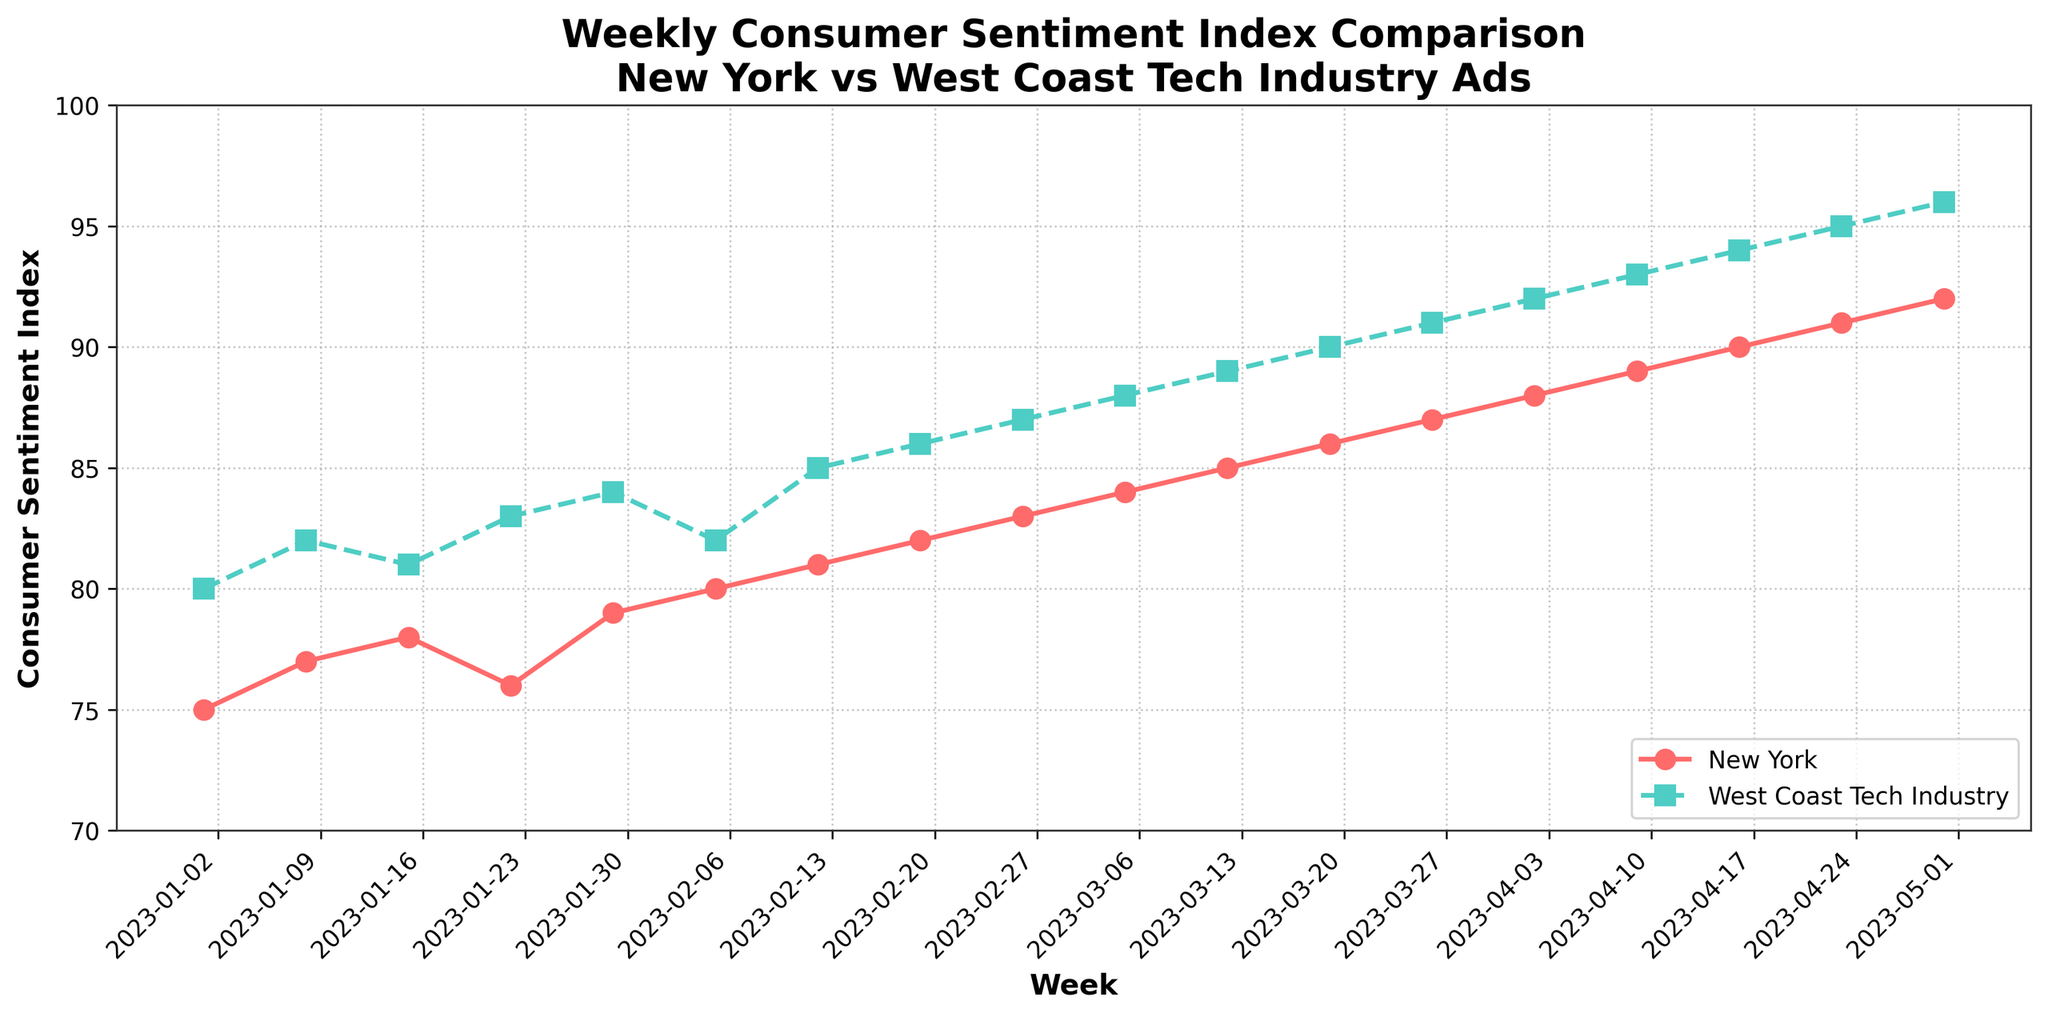How many weeks are displayed in the figure? The x-axis displays the range of dates from the first week of January 2023 to the last week of April 2023. Counting the data points from January 1, 2023, to April 30, 2023, results in 18 weeks.
Answer: 18 What is the title of the figure? The title is directly mentioned at the top of the plot.
Answer: Weekly Consumer Sentiment Index Comparison Between New York and West Coast Tech Industry Ads Which region has a higher consumer sentiment index on 2023-02-26? By inspecting the plot on the week of February 26, the West Coast line is above the New York line.
Answer: West Coast How much did the consumer sentiment index for New York increase from January 1, 2023, to April 30, 2023? Identify the consumer sentiment index for New York on January 1 (75) and April 30 (92) and calculate the difference (92 - 75).
Answer: 17 On which week did both regions have the same consumer sentiment index? By inspecting the plot, the lines for New York and West Coast are equal at the week of February 5 where both show an index of 80.
Answer: 2023-02-05 What is the overall trend of the consumer sentiment index for both regions? The plot shows an upward trend for both New York and the West Coast tech industry ads, as indicated by the increasing values over time.
Answer: Upward Which region had the steepest increase in consumer sentiment index in a single week, and when did it occur? By comparing the week-to-week changes, the West Coast had an increase from 91 to 92 between April 2, 2023, and April 9, 2023, which is a 1-point increase, while New York had several weeks with 1-point increases but none larger.
Answer: April 9, West Coast Is there any week where the consumer sentiment index in New York decreased compared to the previous week? By checking the plot's data for New York, the only noticeable decrease occurs from January 15, 2023, to January 22, 2023 (78 to 76).
Answer: Yes, January 22, 2023 What is the difference in consumer sentiment index between New York and West Coast on April 30, 2023? Identify the values for New York (92) and West Coast (96) on April 30, 2023, and calculate the difference (96 - 92).
Answer: 4 What patterns can you observe in the weekly comparison of the sentiment indices between New York and West Coast? The West Coast consistently maintains a higher consumer sentiment index compared to New York throughout the time range. Both regions show a general upward trajectory with periodic fluctuations.
Answer: West Coast consistently higher with upward trend 